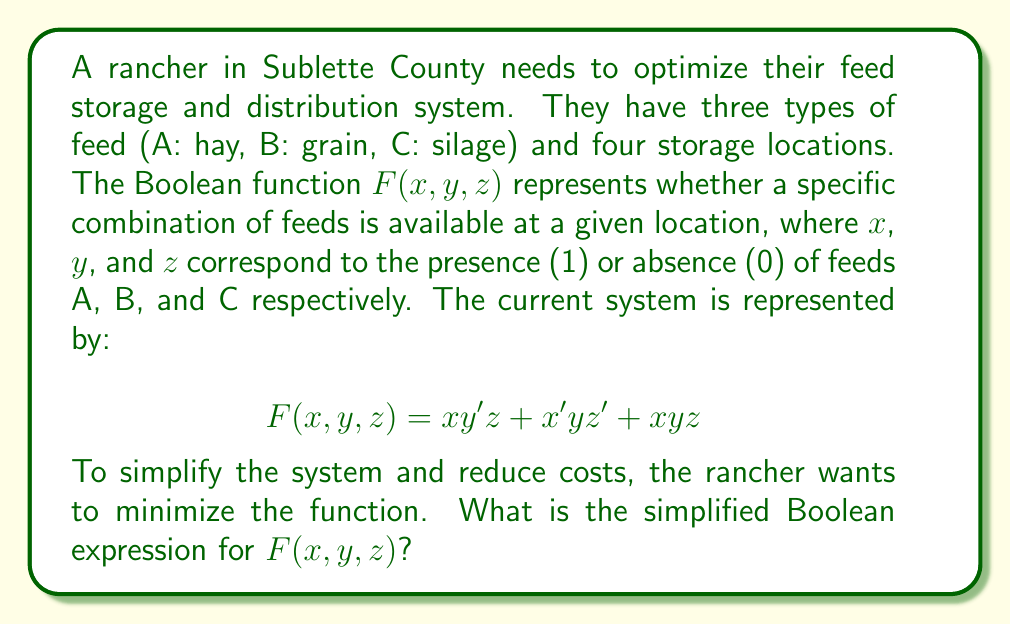Solve this math problem. Let's simplify the Boolean function $F(x,y,z) = xy'z + x'yz' + xyz$ step by step:

1) First, we can use the distributive law to factor out $x$ from the first and third terms:
   $$F(x,y,z) = x(y'z + yz) + x'yz'$$

2) Inside the parentheses, we can factor out $z$:
   $$F(x,y,z) = x(z(y' + y)) + x'yz'$$

3) The term $(y' + y)$ is always true (1) in Boolean algebra, so we can simplify:
   $$F(x,y,z) = xz + x'yz'$$

4) Now, we can use the consensus theorem, which states that for any Boolean function of the form $xy + x'z + yz$, we can add the term $xz$ without changing the function. In our case, we already have $xz$, so we can add $yz$ without changing the function:
   $$F(x,y,z) = xz + x'yz' + yz$$

5) Now we can factor out $z$ from the first and third terms:
   $$F(x,y,z) = z(x + y) + x'yz'$$

This is the minimized form of the function. It represents a simpler system where feed A and C (hay and silage) are stored together, feed B and C (grain and silage) are stored together, and there's a separate storage for when only feed B (grain) is available.
Answer: $z(x + y) + x'yz'$ 